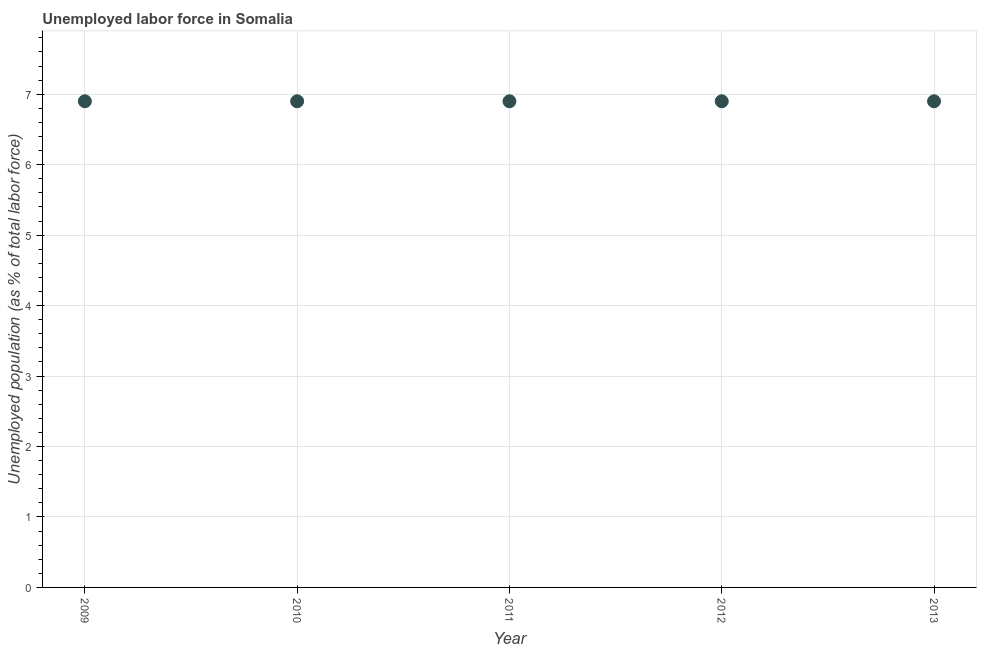What is the total unemployed population in 2009?
Ensure brevity in your answer.  6.9. Across all years, what is the maximum total unemployed population?
Give a very brief answer. 6.9. Across all years, what is the minimum total unemployed population?
Your response must be concise. 6.9. In which year was the total unemployed population maximum?
Provide a short and direct response. 2009. In which year was the total unemployed population minimum?
Your answer should be very brief. 2009. What is the sum of the total unemployed population?
Your answer should be very brief. 34.5. What is the difference between the total unemployed population in 2011 and 2012?
Offer a terse response. 0. What is the average total unemployed population per year?
Ensure brevity in your answer.  6.9. What is the median total unemployed population?
Provide a short and direct response. 6.9. Is the total unemployed population in 2010 less than that in 2011?
Keep it short and to the point. No. Is the difference between the total unemployed population in 2010 and 2011 greater than the difference between any two years?
Your answer should be very brief. Yes. What is the difference between the highest and the second highest total unemployed population?
Make the answer very short. 0. Is the sum of the total unemployed population in 2010 and 2012 greater than the maximum total unemployed population across all years?
Your response must be concise. Yes. Does the total unemployed population monotonically increase over the years?
Provide a short and direct response. No. How many dotlines are there?
Make the answer very short. 1. What is the title of the graph?
Keep it short and to the point. Unemployed labor force in Somalia. What is the label or title of the X-axis?
Offer a terse response. Year. What is the label or title of the Y-axis?
Make the answer very short. Unemployed population (as % of total labor force). What is the Unemployed population (as % of total labor force) in 2009?
Offer a terse response. 6.9. What is the Unemployed population (as % of total labor force) in 2010?
Offer a very short reply. 6.9. What is the Unemployed population (as % of total labor force) in 2011?
Ensure brevity in your answer.  6.9. What is the Unemployed population (as % of total labor force) in 2012?
Make the answer very short. 6.9. What is the Unemployed population (as % of total labor force) in 2013?
Your answer should be compact. 6.9. What is the difference between the Unemployed population (as % of total labor force) in 2009 and 2010?
Your response must be concise. 0. What is the difference between the Unemployed population (as % of total labor force) in 2009 and 2012?
Your answer should be compact. 0. What is the difference between the Unemployed population (as % of total labor force) in 2009 and 2013?
Keep it short and to the point. 0. What is the difference between the Unemployed population (as % of total labor force) in 2010 and 2011?
Make the answer very short. 0. What is the difference between the Unemployed population (as % of total labor force) in 2011 and 2012?
Offer a very short reply. 0. What is the difference between the Unemployed population (as % of total labor force) in 2011 and 2013?
Give a very brief answer. 0. What is the difference between the Unemployed population (as % of total labor force) in 2012 and 2013?
Your answer should be compact. 0. What is the ratio of the Unemployed population (as % of total labor force) in 2012 to that in 2013?
Your answer should be compact. 1. 